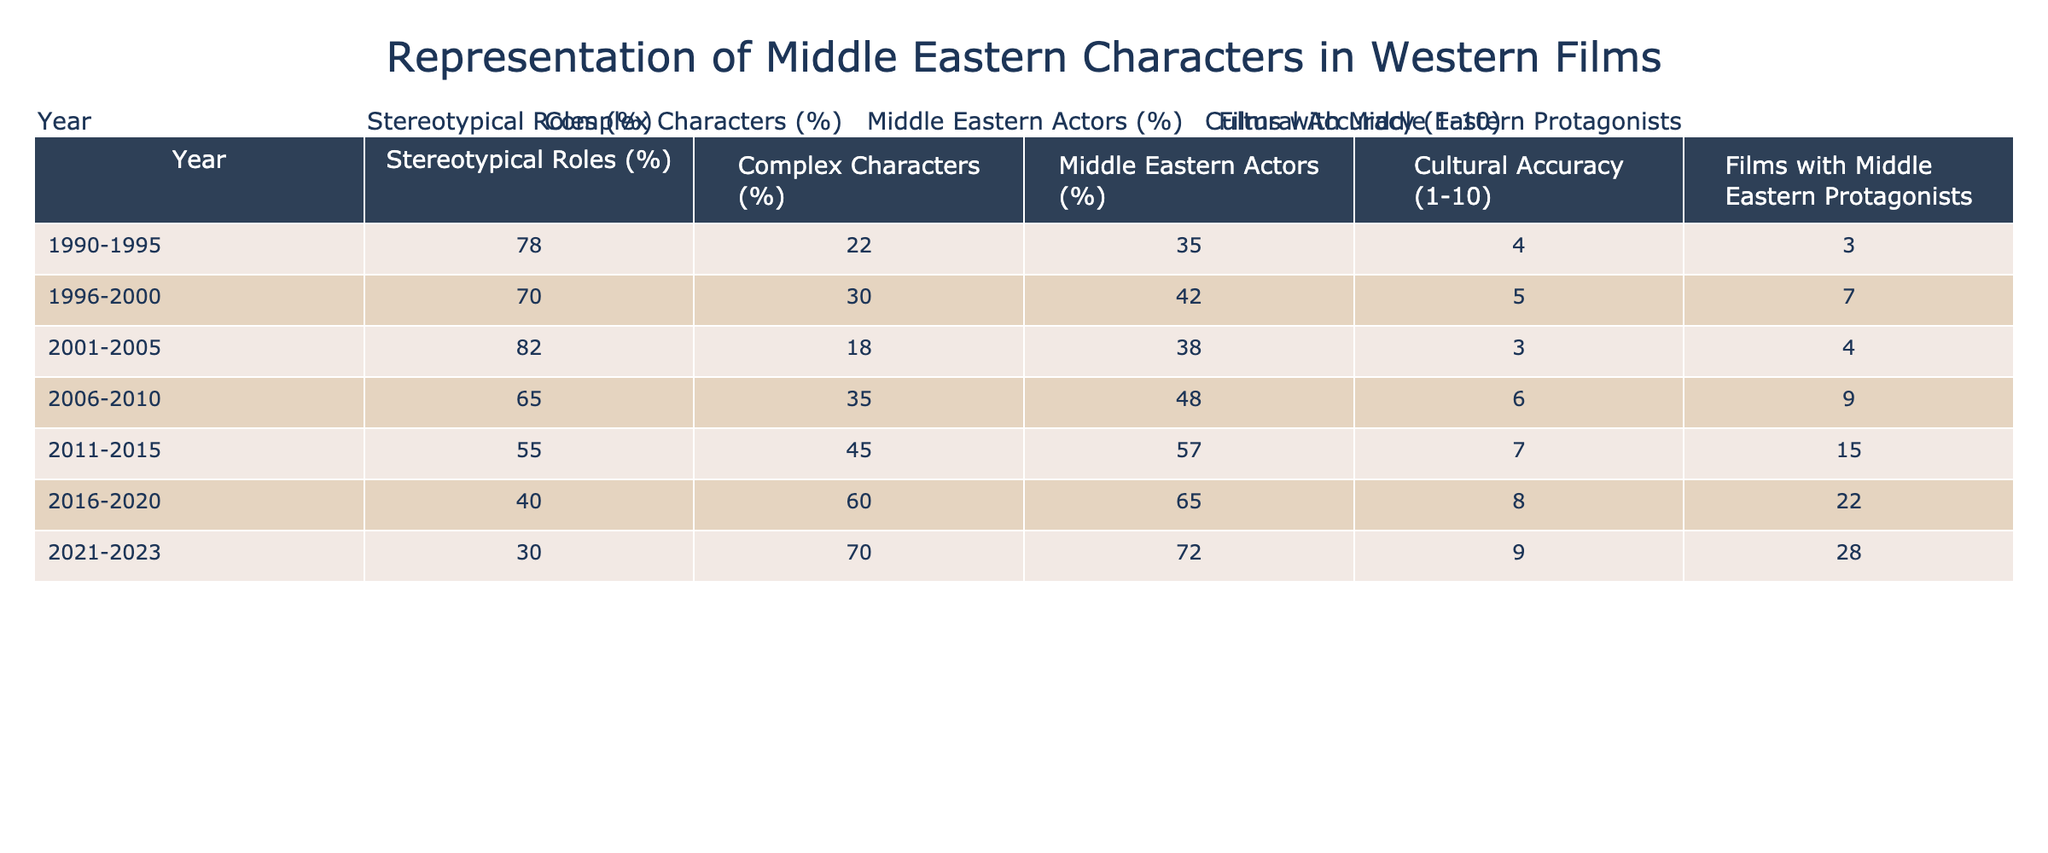What percentage of Middle Eastern characters were portrayed in stereotypical roles between 2011 and 2015? The table shows that in the years 2011-2015, the percentage of stereotypical roles for Middle Eastern characters was 55% according to the data provided.
Answer: 55% What was the increase in films with Middle Eastern protagonists from 1990-1995 to 2021-2023? In 1990-1995, there were 3 films and in 2021-2023, there were 28 films, so the increase is 28 - 3 = 25 films.
Answer: 25 films What is the average cultural accuracy rating for the years 1990-2010? To find the average, sum the cultural accuracy scores from 1990-2010 (4 + 5 + 3 + 6 + 7) = 25 and divide by the 5 years which gives 25 / 5 = 5.
Answer: 5 Did the percentage of complex characters in Western films increase every five-year period? Comparing the data: 22%, 30%, 18%, 35%, 45%, 60%, and 70%, it shows that after an initial decrease between 2001-2005 and 2006-2010, it increased in subsequent years. Thus the statement is false.
Answer: No What was the trend in the percentage of Middle Eastern actors from 1996-2000 to 2021-2023? From the data, the percentage of Middle Eastern actors increased from 42% to 72% over that period, showing a clear upward trend.
Answer: Increased What is the difference in the percentage of complex characters between 2001-2005 and 2016-2020? The percentage of complex characters for 2001-2005 was 18% and for 2016-2020 was 60%; thus, the difference is 60% - 18% = 42%.
Answer: 42% What year saw the peak in cultural accuracy rating? The highest rating is a 9 in the years 2021-2023, indicating it was the peak year for cultural accuracy.
Answer: 2021-2023 What percentage of the roles in Western films were stereotypical in the last recorded period? In the period of 2021-2023, the table indicates that 30% of the roles were stereotypical.
Answer: 30% How many more films with Middle Eastern protagonists were there in the period of 2016-2020 compared to 1996-2000? In 2016-2020, there were 22 films and in 1996-2000, there were 7 films, so the difference is 22 - 7 = 15 films.
Answer: 15 films What is the trend for the percentage of Middle Eastern actors from 1990-1995 to 2021-2023? The percentage increased from 35% to 72% over the stated period, indicating a positive trend for representation of Middle Eastern actors.
Answer: Positive trend In which five-year period was the lowest percentage of stereotypical roles recorded? The lowest percentage of stereotypical roles was recorded in the period 2021-2023 at 30%.
Answer: 2021-2023 